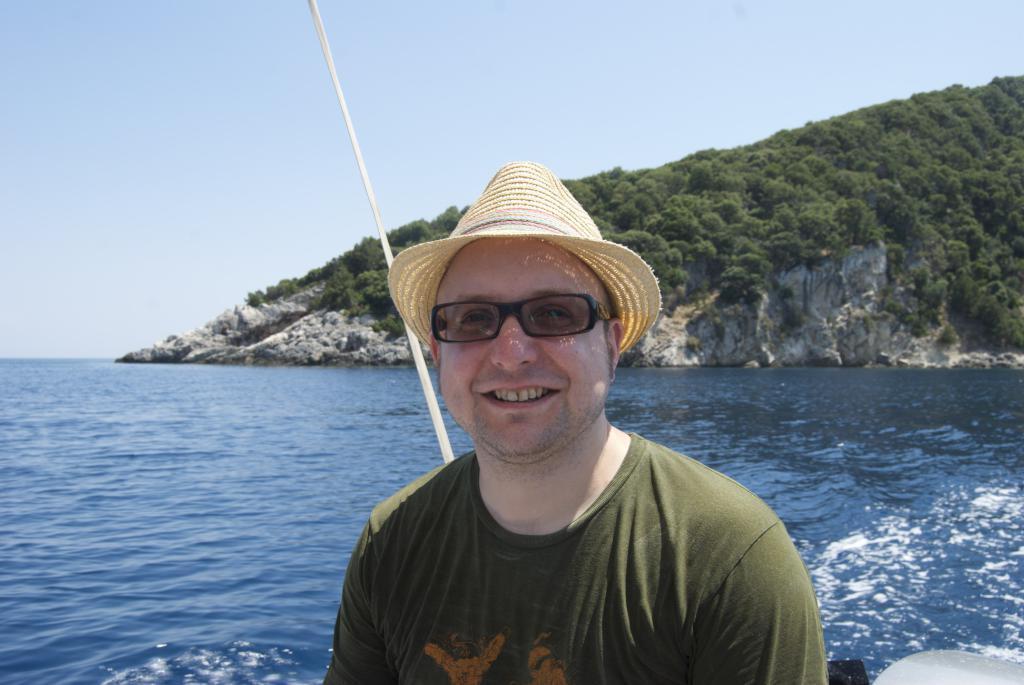Can you describe this image briefly? In the foreground of the image we can see a person where he wore a hat. In the middle of the image we can see the hills, trees and water body. On the top of the image we can see the sky. 